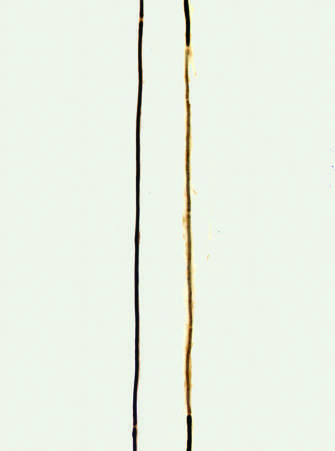what is a normal axon with a long thick dark myelin internode flanked by?
Answer the question using a single word or phrase. Nodes of ranvier with a long thick dark myelin internode 